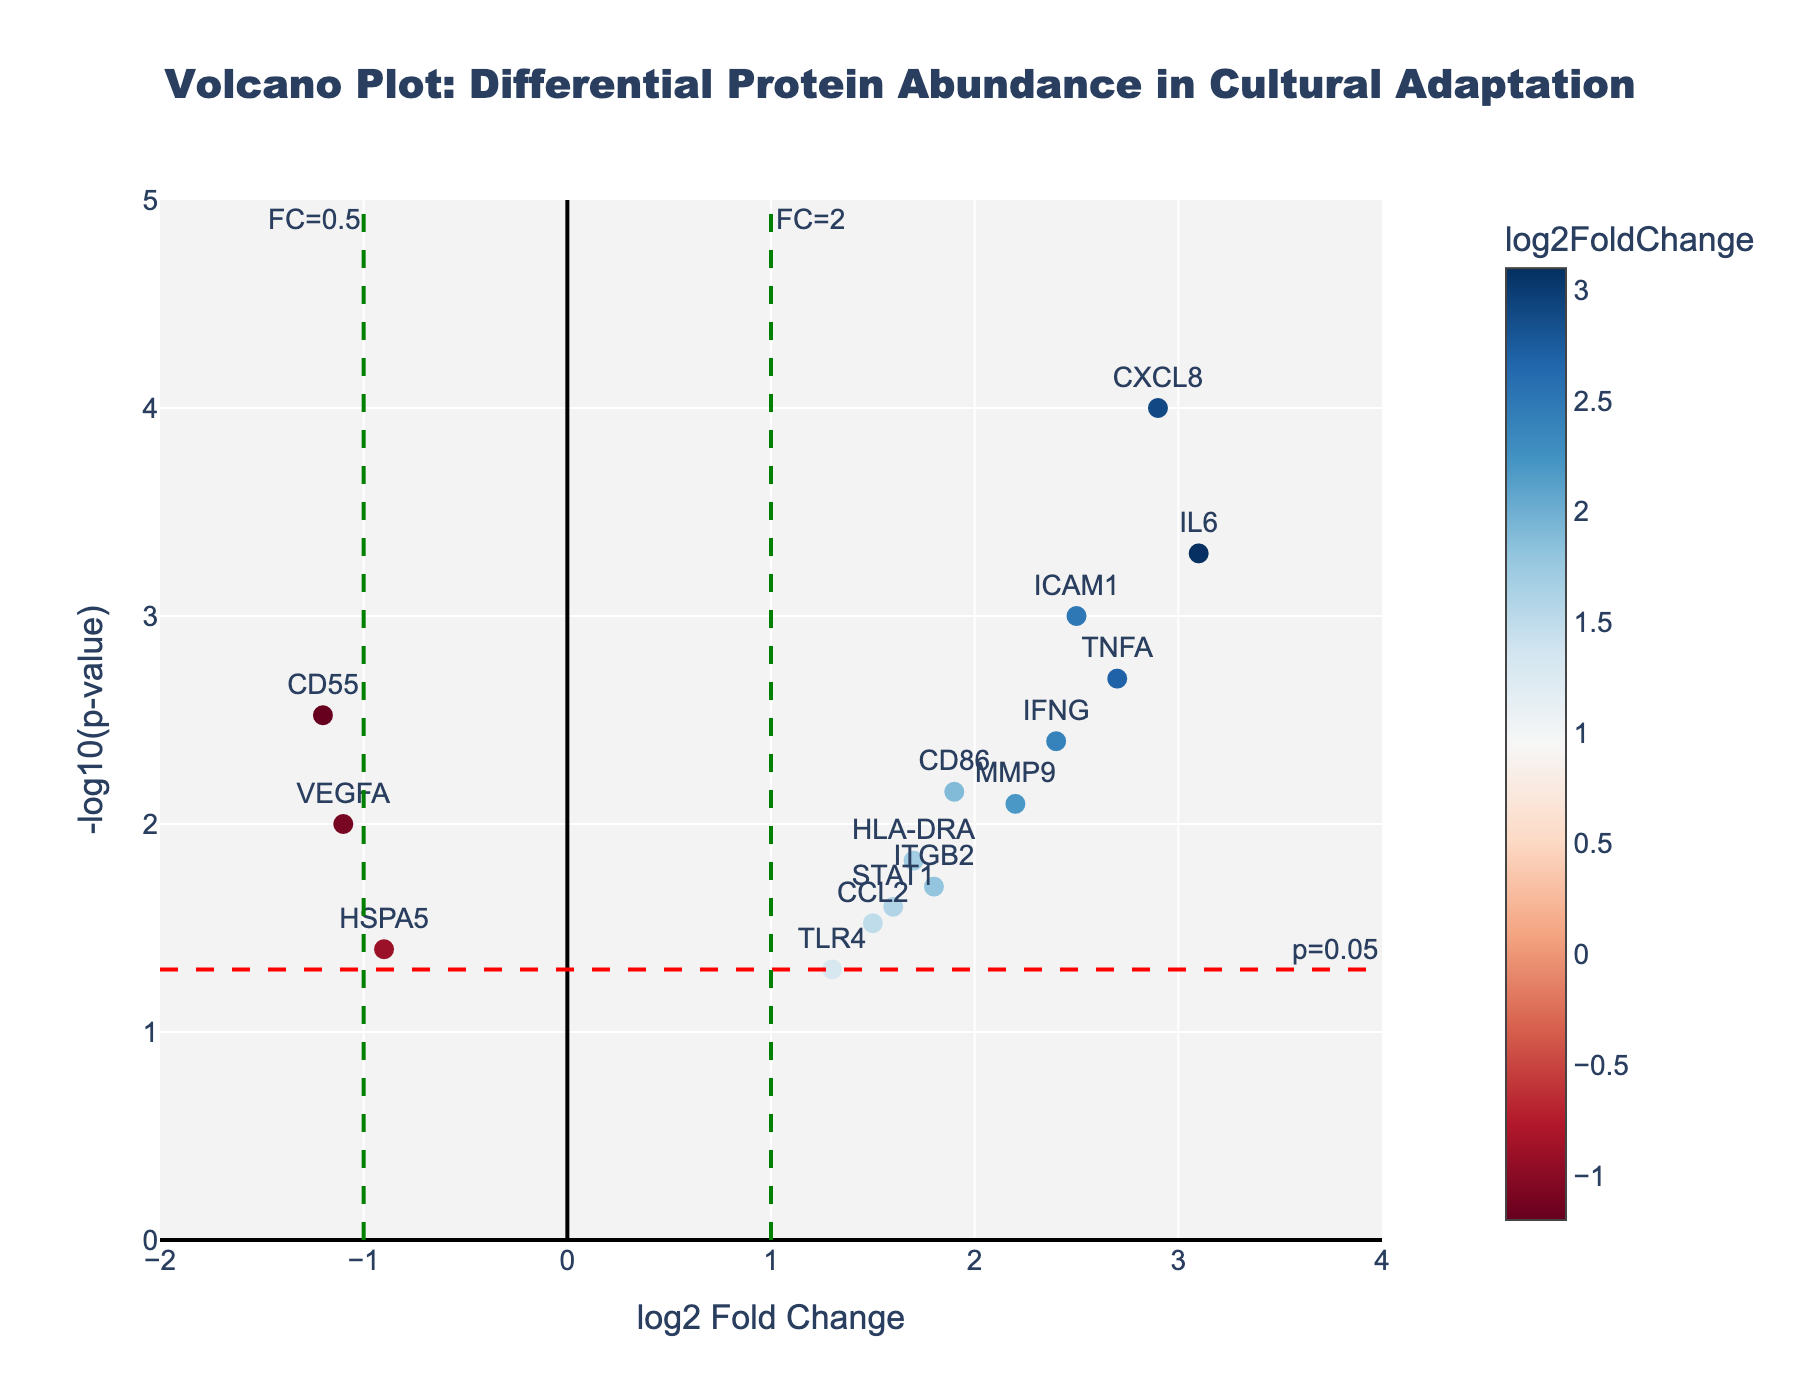What is the title of the plot? The title is clearly displayed at the top of the figure, reading "Volcano Plot: Differential Protein Abundance in Cultural Adaptation."
Answer: Volcano Plot: Differential Protein Abundance in Cultural Adaptation What are the axes labeled? The X-axis represents "log2 Fold Change" and the Y-axis represents "-log10(p-value)". These labels help to understand the meaning of the data points in the plot.
Answer: log2 Fold Change (X-axis) and -log10(p-value) (Y-axis) How many proteins have a p-value less than 0.05? Identify the proteins above the red significance line on the Y-axis (-log10(p-value) line); these proteins have p-values less than 0.05. There are 13 proteins above this line.
Answer: 13 Which protein shows the highest log2 Fold Change? Locate the furthest right data point on the X-axis since log2 Fold Change increases to the right. The data point furthest to the right represents IL6.
Answer: IL6 How many proteins have a log2 Fold Change greater than 1? Identify data points to the right of the green line at x=1. There are 9 proteins with a log2 Fold Change greater than 1.
Answer: 9 Which protein shows the smallest p-value? Find the highest point on the Y-axis because -log10(p-value) means higher up is a smaller p-value. CXCL8 has the smallest p-value.
Answer: CXCL8 Which proteins are downregulated and have significant p-values? Downregulated proteins have a negative log2 Fold Change (left side of the plot). Significant proteins are above the red line at y=1.3. The downregulated proteins with significant p-values are CD55 and VEGFA.
Answer: CD55 and VEGFA What is the log2 Fold Change and p-value for TNFA? Locate the data point labeled TNFA. Its x-coordinate (log2 Fold Change) is about 2.7 and y-coordinate (-log10(p-value)) is about 2.7, corresponding to a p-value of approximately 0.002.
Answer: log2 Fold Change: 2.7, p-value: 0.002 Which protein has a log2 Fold Change closest to 2? Look at the data points near x=2. ICAM1, with a log2 Fold Change of exactly 2.5, is the closest to 2.
Answer: ICAM1 